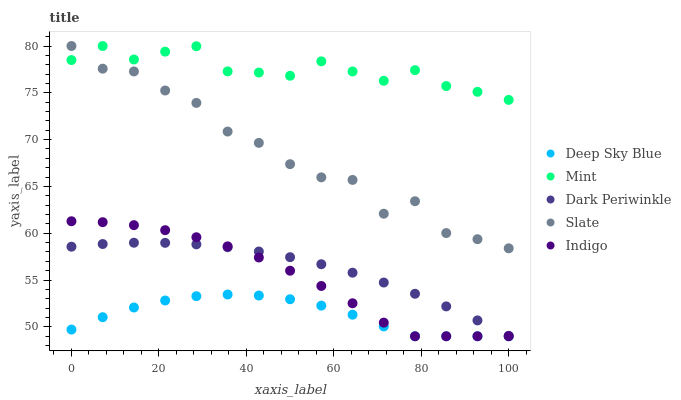Does Deep Sky Blue have the minimum area under the curve?
Answer yes or no. Yes. Does Mint have the maximum area under the curve?
Answer yes or no. Yes. Does Slate have the minimum area under the curve?
Answer yes or no. No. Does Slate have the maximum area under the curve?
Answer yes or no. No. Is Dark Periwinkle the smoothest?
Answer yes or no. Yes. Is Slate the roughest?
Answer yes or no. Yes. Is Mint the smoothest?
Answer yes or no. No. Is Mint the roughest?
Answer yes or no. No. Does Indigo have the lowest value?
Answer yes or no. Yes. Does Slate have the lowest value?
Answer yes or no. No. Does Mint have the highest value?
Answer yes or no. Yes. Does Dark Periwinkle have the highest value?
Answer yes or no. No. Is Dark Periwinkle less than Mint?
Answer yes or no. Yes. Is Dark Periwinkle greater than Deep Sky Blue?
Answer yes or no. Yes. Does Deep Sky Blue intersect Indigo?
Answer yes or no. Yes. Is Deep Sky Blue less than Indigo?
Answer yes or no. No. Is Deep Sky Blue greater than Indigo?
Answer yes or no. No. Does Dark Periwinkle intersect Mint?
Answer yes or no. No. 